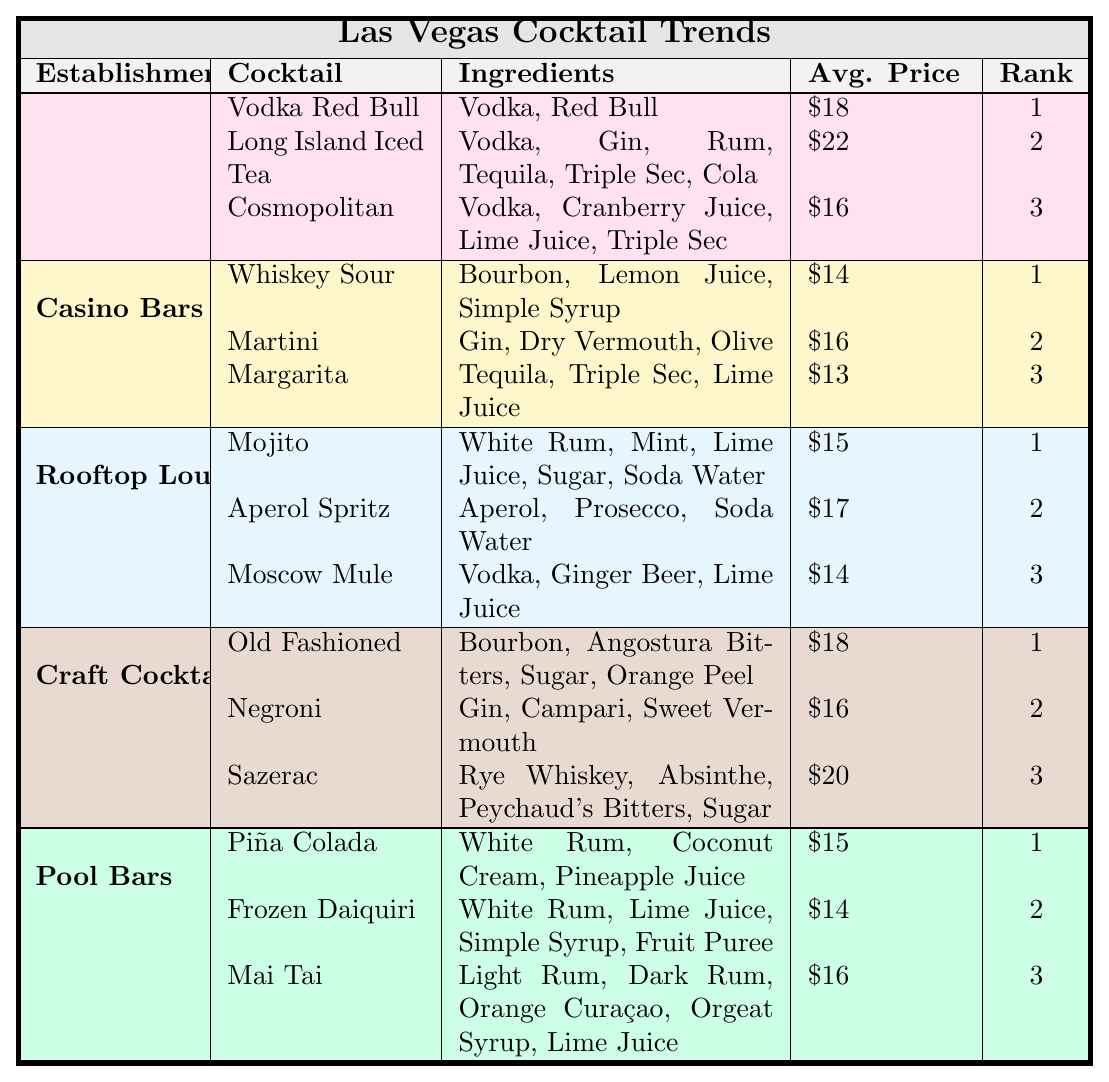What is the average price of cocktails at nightclubs? The average price of cocktails at nightclubs is calculated by adding the prices of three cocktails: $18 (Vodka Red Bull), $22 (Long Island Iced Tea), and $16 (Cosmopolitan). The total is $18 + $22 + $16 = $56. Dividing by the number of cocktails (3) gives the average: $56 / 3 = $18.67.
Answer: $18.67 Which cocktail has the highest popularity rank at pool bars? At pool bars, the highest popularity rank is 1. The cocktail that holds this rank is the Piña Colada.
Answer: Piña Colada Is the average price of the "Sazerac" more expensive than the "Margarita"? The Sazerac has an average price of $20, while the Margarita has a price of $13. Comparing these values, $20 is indeed greater than $13.
Answer: Yes What is the most expensive cocktail among those served at casinos? The cocktails served at casino bars have the following prices: Whiskey Sour - $14, Martini - $16, and Margarita - $13. The most expensive is the Martini at $16.
Answer: Martini How many cocktails listed in the table have vodka as an ingredient? The cocktails containing vodka are Vodka Red Bull, Cosmopolitan, and Moscow Mule. This makes a total of 3 cocktails.
Answer: 3 Which establishment type offers the least expensive cocktail? Among all establishment types, the Margarita from casino bars is the least expensive at $13.
Answer: Casino Bars What is the difference in average prices between cocktails at nightclubs and rooftop lounges? The average price at nightclubs is $18.67 (calculated previously) and at rooftop lounges, it is $15. The difference is $18.67 - $15 = $3.67.
Answer: $3.67 Are all cocktails with the word "Daiquiri" more expensive than the "Mojito"? The Frozen Daiquiri is priced at $14 and the Mojito at $15. The Frozen Daiquiri is less expensive; therefore, not all Daiquiris are more expensive than the Mojito.
Answer: No What establishment type serves the "Old Fashioned"? The Old Fashioned is served at Craft Cocktail Bars as indicated in the table.
Answer: Craft Cocktail Bars What is the total average price of the top three cocktails in nightclubs? The top three cocktails in nightclubs are priced at $18, $22, and $16. Their total average price is calculated as follows: $18 + $22 + $16 = $56, then divided by 3 gives $56 / 3 = $18.67.
Answer: $18.67 